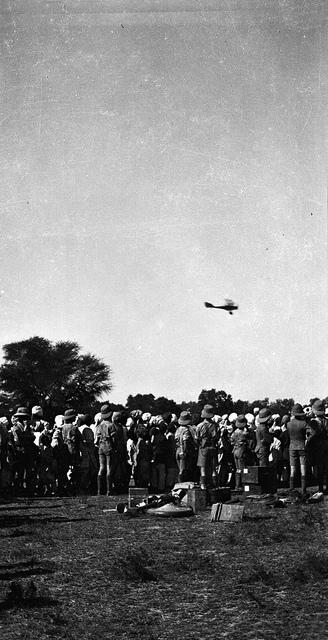Is there any trees in the picture?
Answer briefly. Yes. What is the crowd looking at?
Be succinct. Plane. What is in the sky?
Quick response, please. Plane. 